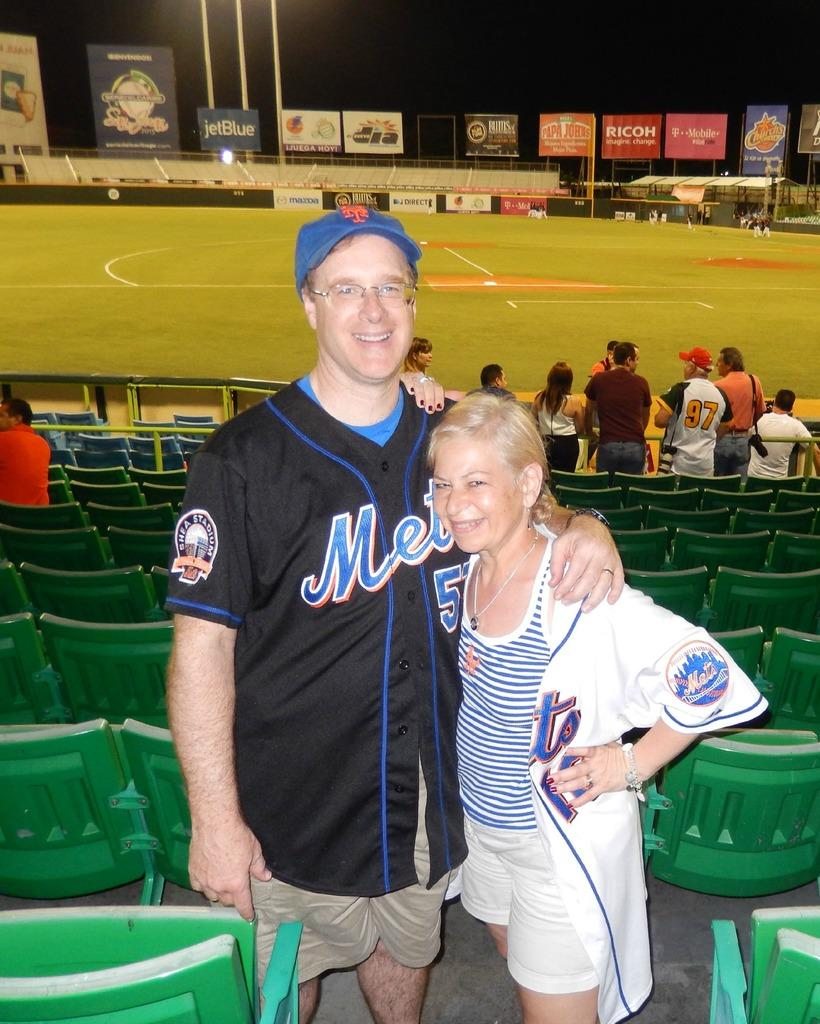<image>
Offer a succinct explanation of the picture presented. A couple wearing Mets jerseys pose in the stands. 